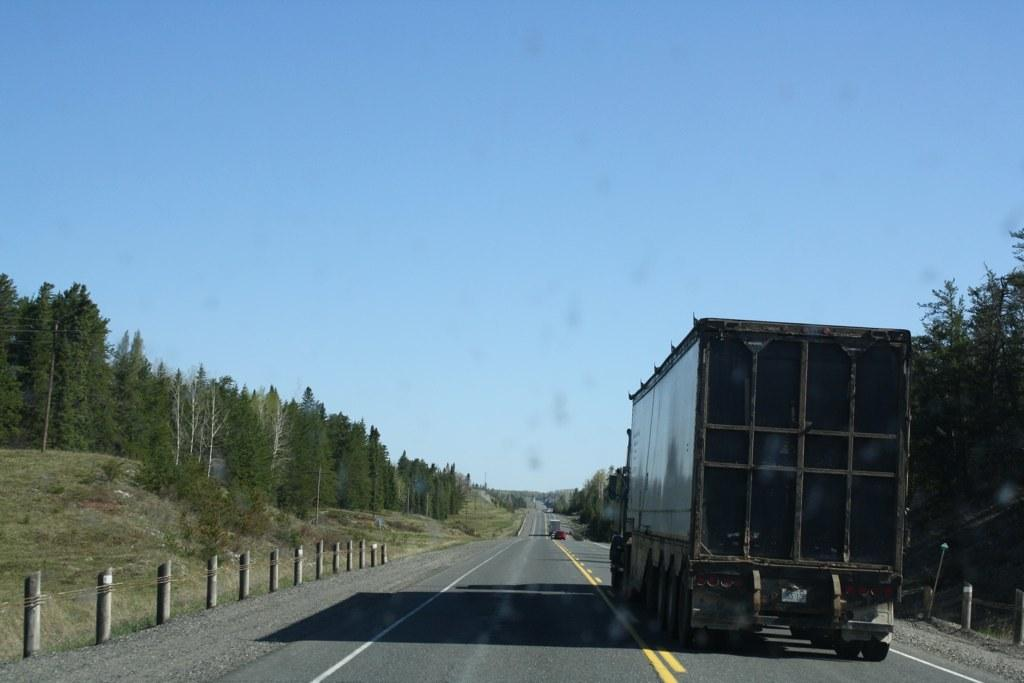What can be seen on the road in the image? There are vehicles on the road in the image. What type of barrier is visible in the image? There is a fence visible in the image. What type of vegetation is present in the image? There are trees in the image, and grass is present on the ground. What is visible at the top of the image? The sky is visible at the top of the image. What type of lunch is the grandfather eating in the image? There is no grandfather or lunch present in the image. How many pigs are visible in the image? There are no pigs present in the image. 